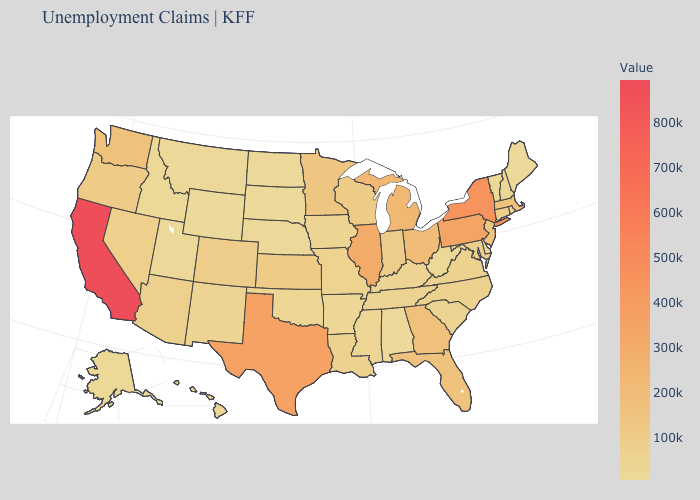Among the states that border Vermont , which have the lowest value?
Answer briefly. New Hampshire. Does Wyoming have the lowest value in the USA?
Answer briefly. Yes. Does South Dakota have a lower value than California?
Be succinct. Yes. Which states hav the highest value in the MidWest?
Write a very short answer. Illinois. Which states hav the highest value in the West?
Keep it brief. California. Among the states that border Georgia , which have the highest value?
Be succinct. Florida. 